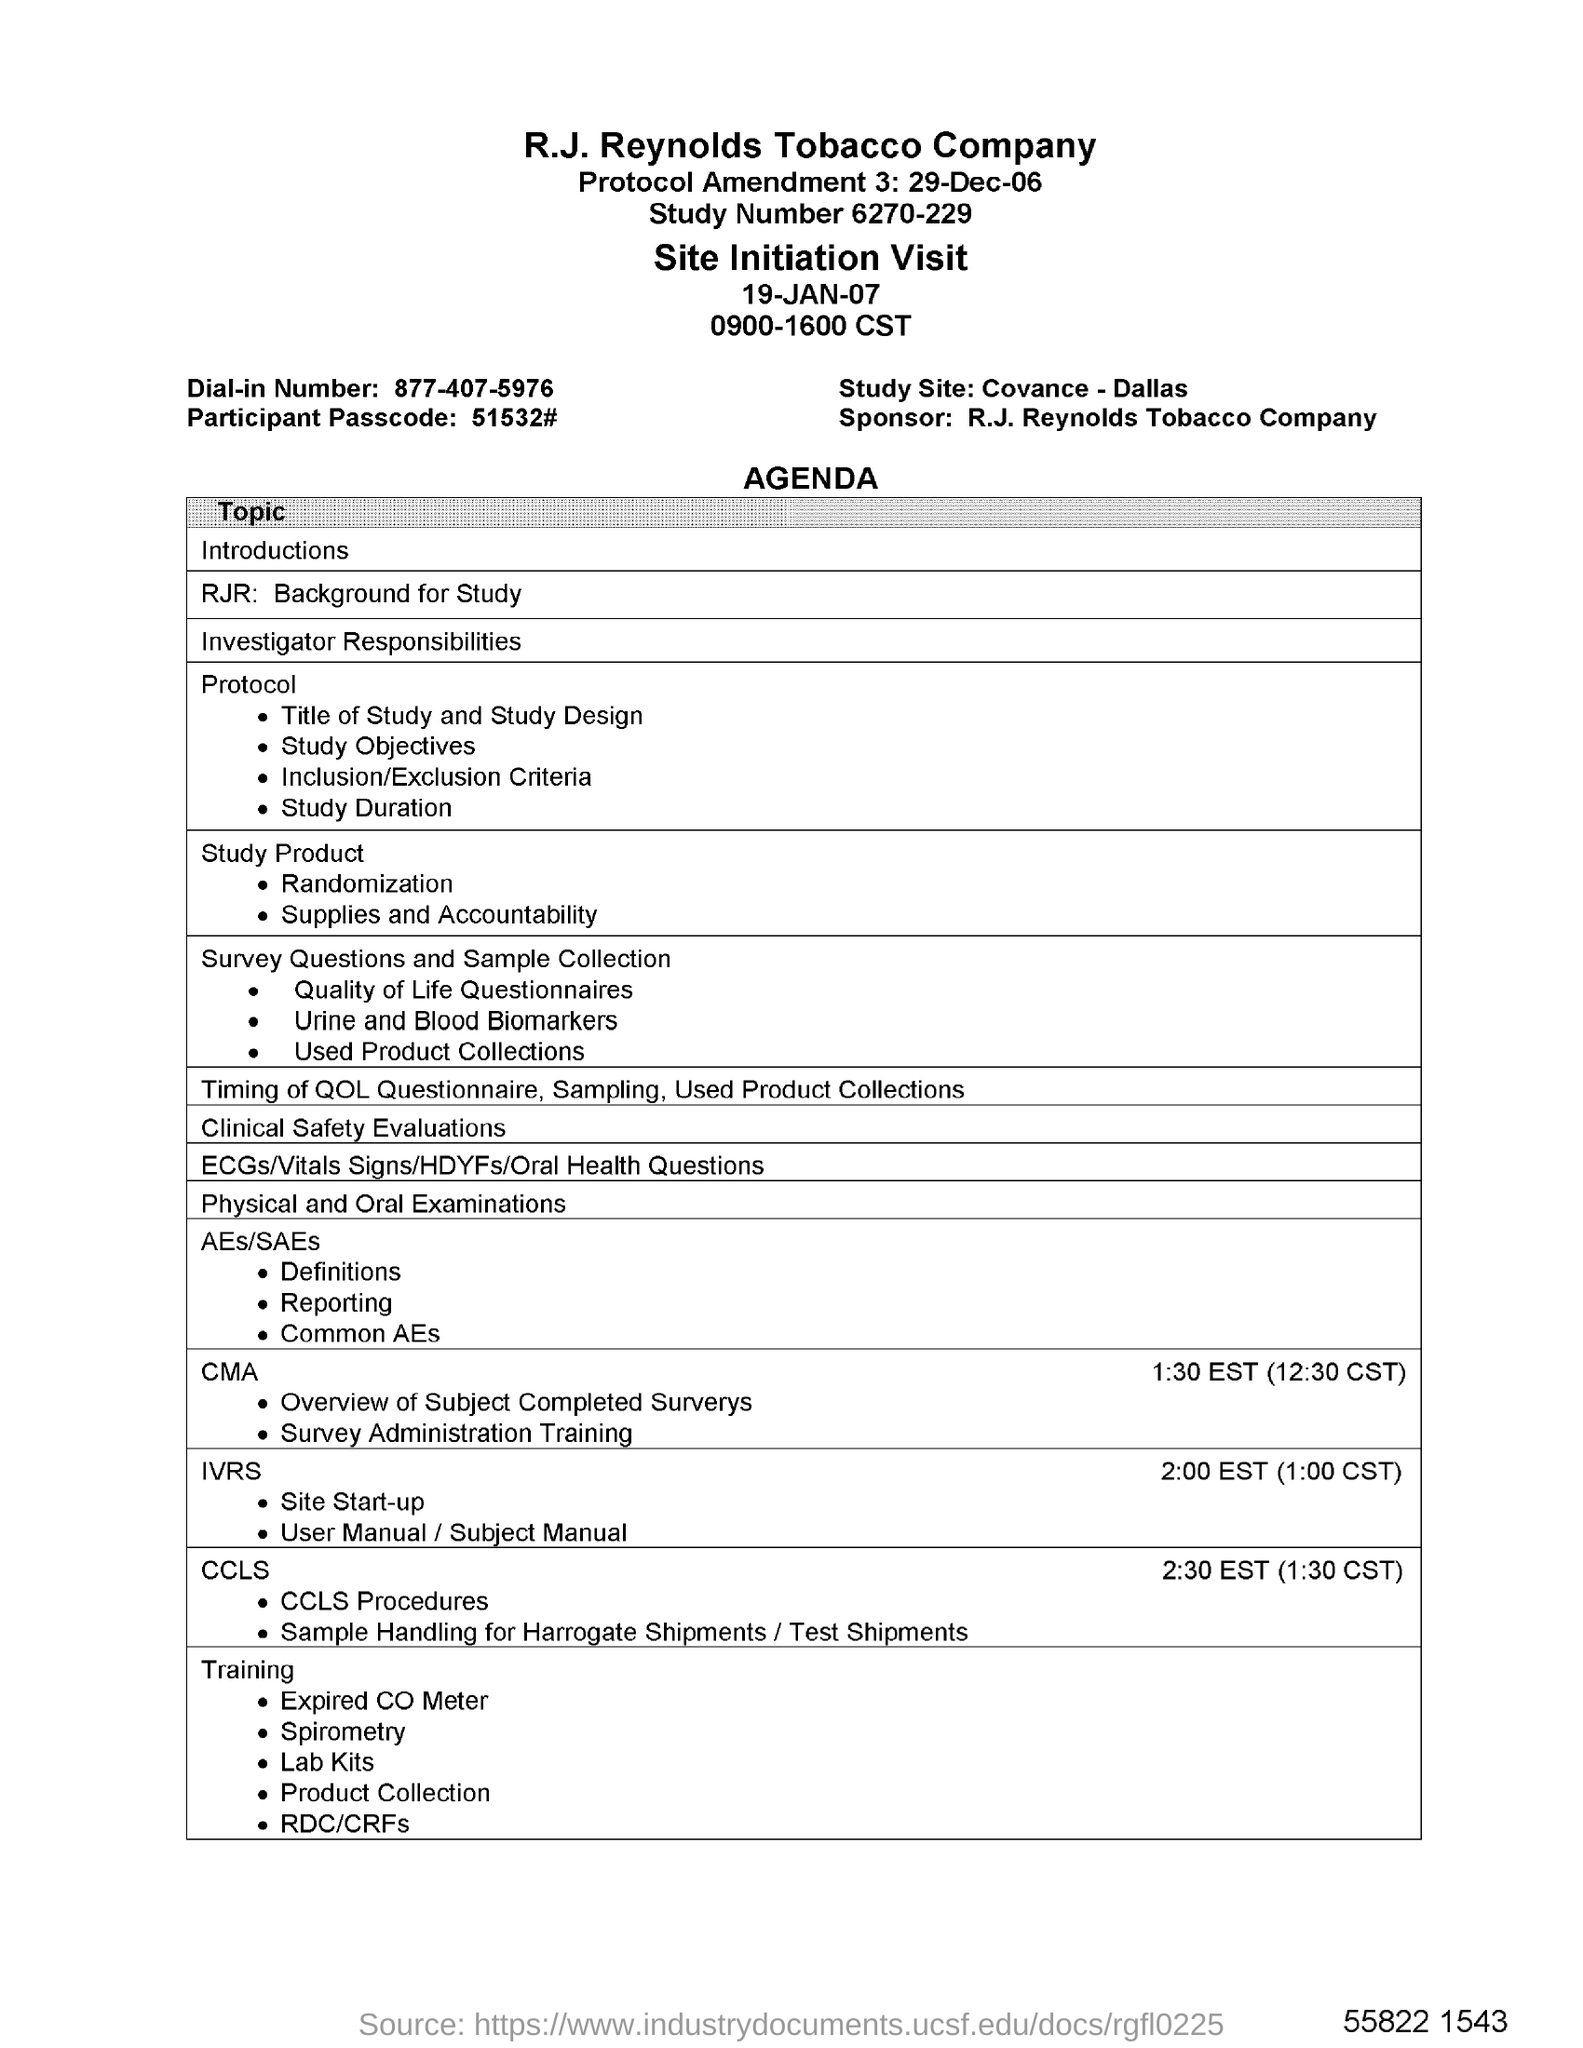What is the Study Number?
Provide a succinct answer. 6270-229. Which is the Study Site?
Ensure brevity in your answer.  Covance - Dallas. What is the Participant Passcode?
Provide a succinct answer. 51532#. Who is the sponsor?
Keep it short and to the point. R.J. Reynolds Tobacco Company. 